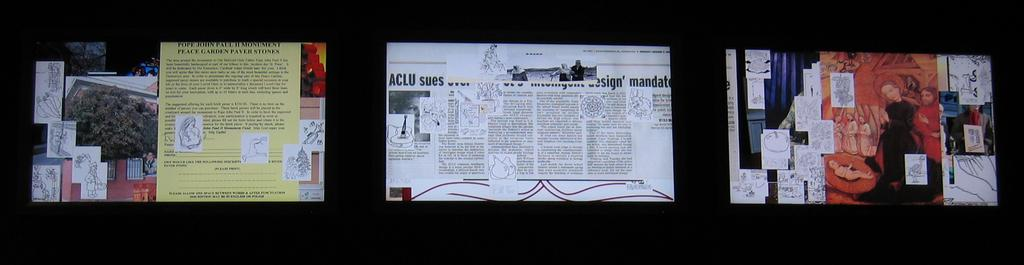What type of artwork is depicted in the image? The image is a collage. What elements are included in the collage? There are photos, words on papers, and paragraphs on papers in the collage. Can you see a frog wearing a hat in the collage? There is no frog or hat present in the collage; it only contains photos, words on papers, and paragraphs on papers. 